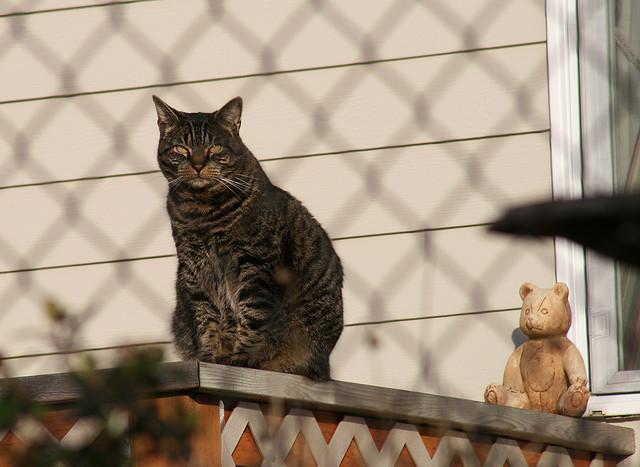How many bears are on the rock?
Give a very brief answer. 0. 